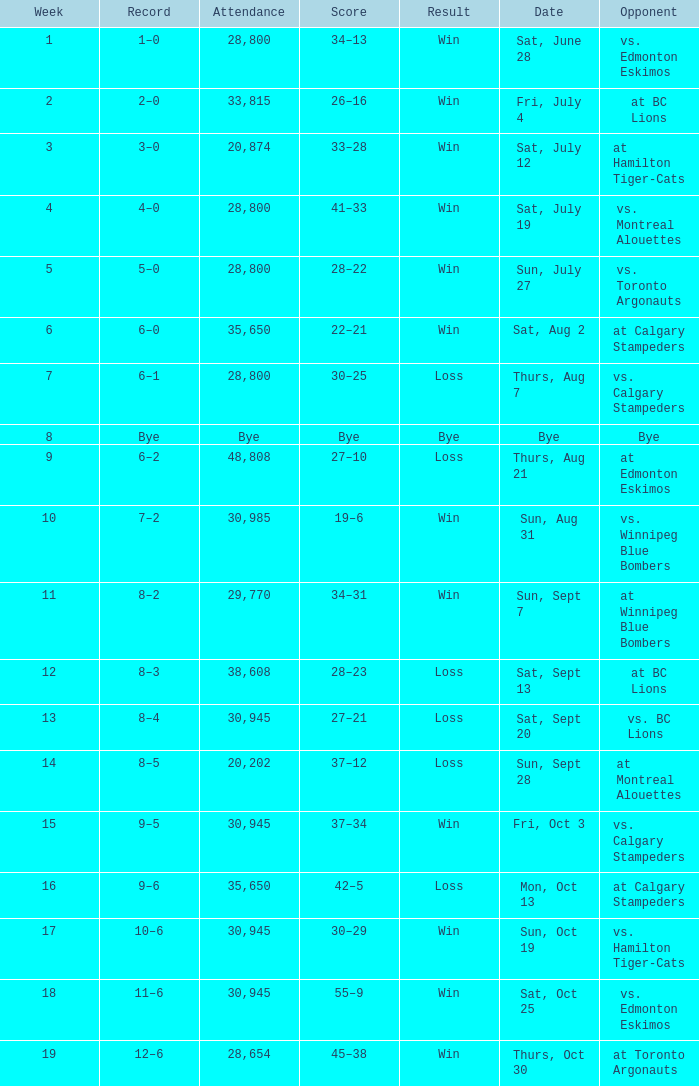What was the date of the game with an attendance of 20,874 fans? Sat, July 12. Would you mind parsing the complete table? {'header': ['Week', 'Record', 'Attendance', 'Score', 'Result', 'Date', 'Opponent'], 'rows': [['1', '1–0', '28,800', '34–13', 'Win', 'Sat, June 28', 'vs. Edmonton Eskimos'], ['2', '2–0', '33,815', '26–16', 'Win', 'Fri, July 4', 'at BC Lions'], ['3', '3–0', '20,874', '33–28', 'Win', 'Sat, July 12', 'at Hamilton Tiger-Cats'], ['4', '4–0', '28,800', '41–33', 'Win', 'Sat, July 19', 'vs. Montreal Alouettes'], ['5', '5–0', '28,800', '28–22', 'Win', 'Sun, July 27', 'vs. Toronto Argonauts'], ['6', '6–0', '35,650', '22–21', 'Win', 'Sat, Aug 2', 'at Calgary Stampeders'], ['7', '6–1', '28,800', '30–25', 'Loss', 'Thurs, Aug 7', 'vs. Calgary Stampeders'], ['8', 'Bye', 'Bye', 'Bye', 'Bye', 'Bye', 'Bye'], ['9', '6–2', '48,808', '27–10', 'Loss', 'Thurs, Aug 21', 'at Edmonton Eskimos'], ['10', '7–2', '30,985', '19–6', 'Win', 'Sun, Aug 31', 'vs. Winnipeg Blue Bombers'], ['11', '8–2', '29,770', '34–31', 'Win', 'Sun, Sept 7', 'at Winnipeg Blue Bombers'], ['12', '8–3', '38,608', '28–23', 'Loss', 'Sat, Sept 13', 'at BC Lions'], ['13', '8–4', '30,945', '27–21', 'Loss', 'Sat, Sept 20', 'vs. BC Lions'], ['14', '8–5', '20,202', '37–12', 'Loss', 'Sun, Sept 28', 'at Montreal Alouettes'], ['15', '9–5', '30,945', '37–34', 'Win', 'Fri, Oct 3', 'vs. Calgary Stampeders'], ['16', '9–6', '35,650', '42–5', 'Loss', 'Mon, Oct 13', 'at Calgary Stampeders'], ['17', '10–6', '30,945', '30–29', 'Win', 'Sun, Oct 19', 'vs. Hamilton Tiger-Cats'], ['18', '11–6', '30,945', '55–9', 'Win', 'Sat, Oct 25', 'vs. Edmonton Eskimos'], ['19', '12–6', '28,654', '45–38', 'Win', 'Thurs, Oct 30', 'at Toronto Argonauts']]} 